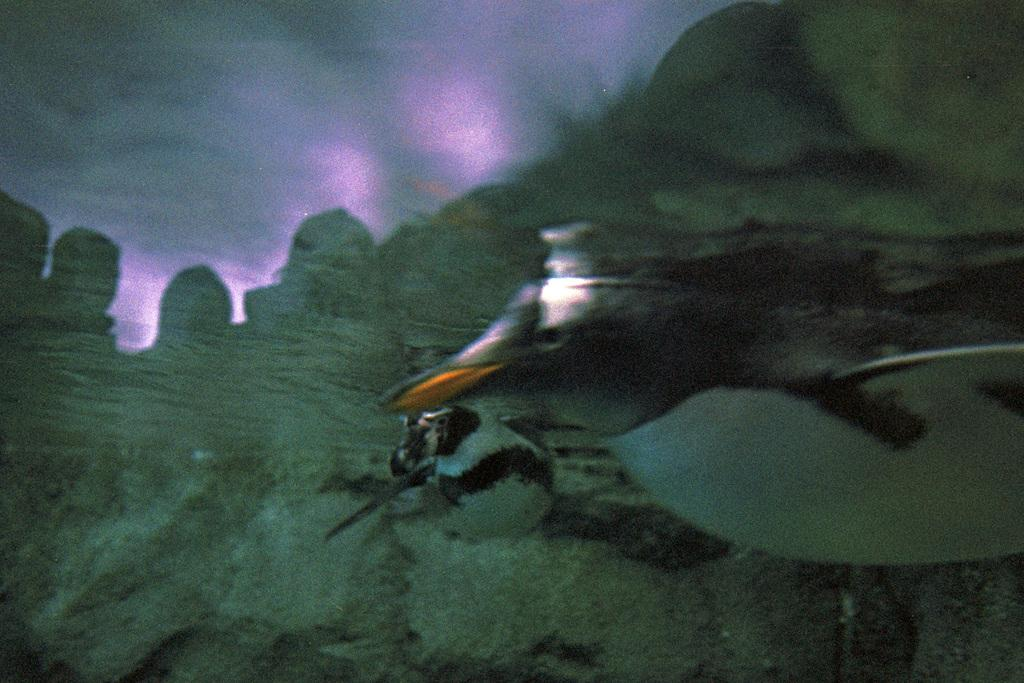What animals are present in the image? There are two penguins in the image. What are the penguins doing in the image? The penguins are swimming in the water. Can you describe anything else visible in the image? There are shadows of humans on the left side of the image. What type of mark can be seen on the penguin's beak in the image? There is no mark visible on the penguins' beaks in the image. How does the penguin's breath affect the water in the image? The image does not show the penguins' breath, so it cannot be determined how it affects the water. 